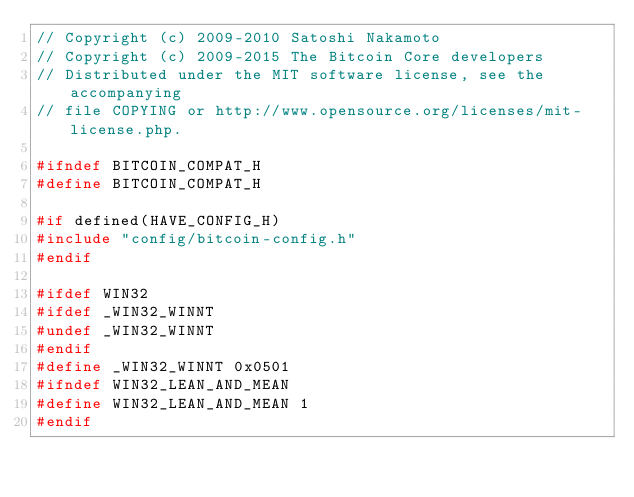Convert code to text. <code><loc_0><loc_0><loc_500><loc_500><_C_>// Copyright (c) 2009-2010 Satoshi Nakamoto
// Copyright (c) 2009-2015 The Bitcoin Core developers
// Distributed under the MIT software license, see the accompanying
// file COPYING or http://www.opensource.org/licenses/mit-license.php.

#ifndef BITCOIN_COMPAT_H
#define BITCOIN_COMPAT_H

#if defined(HAVE_CONFIG_H)
#include "config/bitcoin-config.h"
#endif

#ifdef WIN32
#ifdef _WIN32_WINNT
#undef _WIN32_WINNT
#endif
#define _WIN32_WINNT 0x0501
#ifndef WIN32_LEAN_AND_MEAN
#define WIN32_LEAN_AND_MEAN 1
#endif</code> 